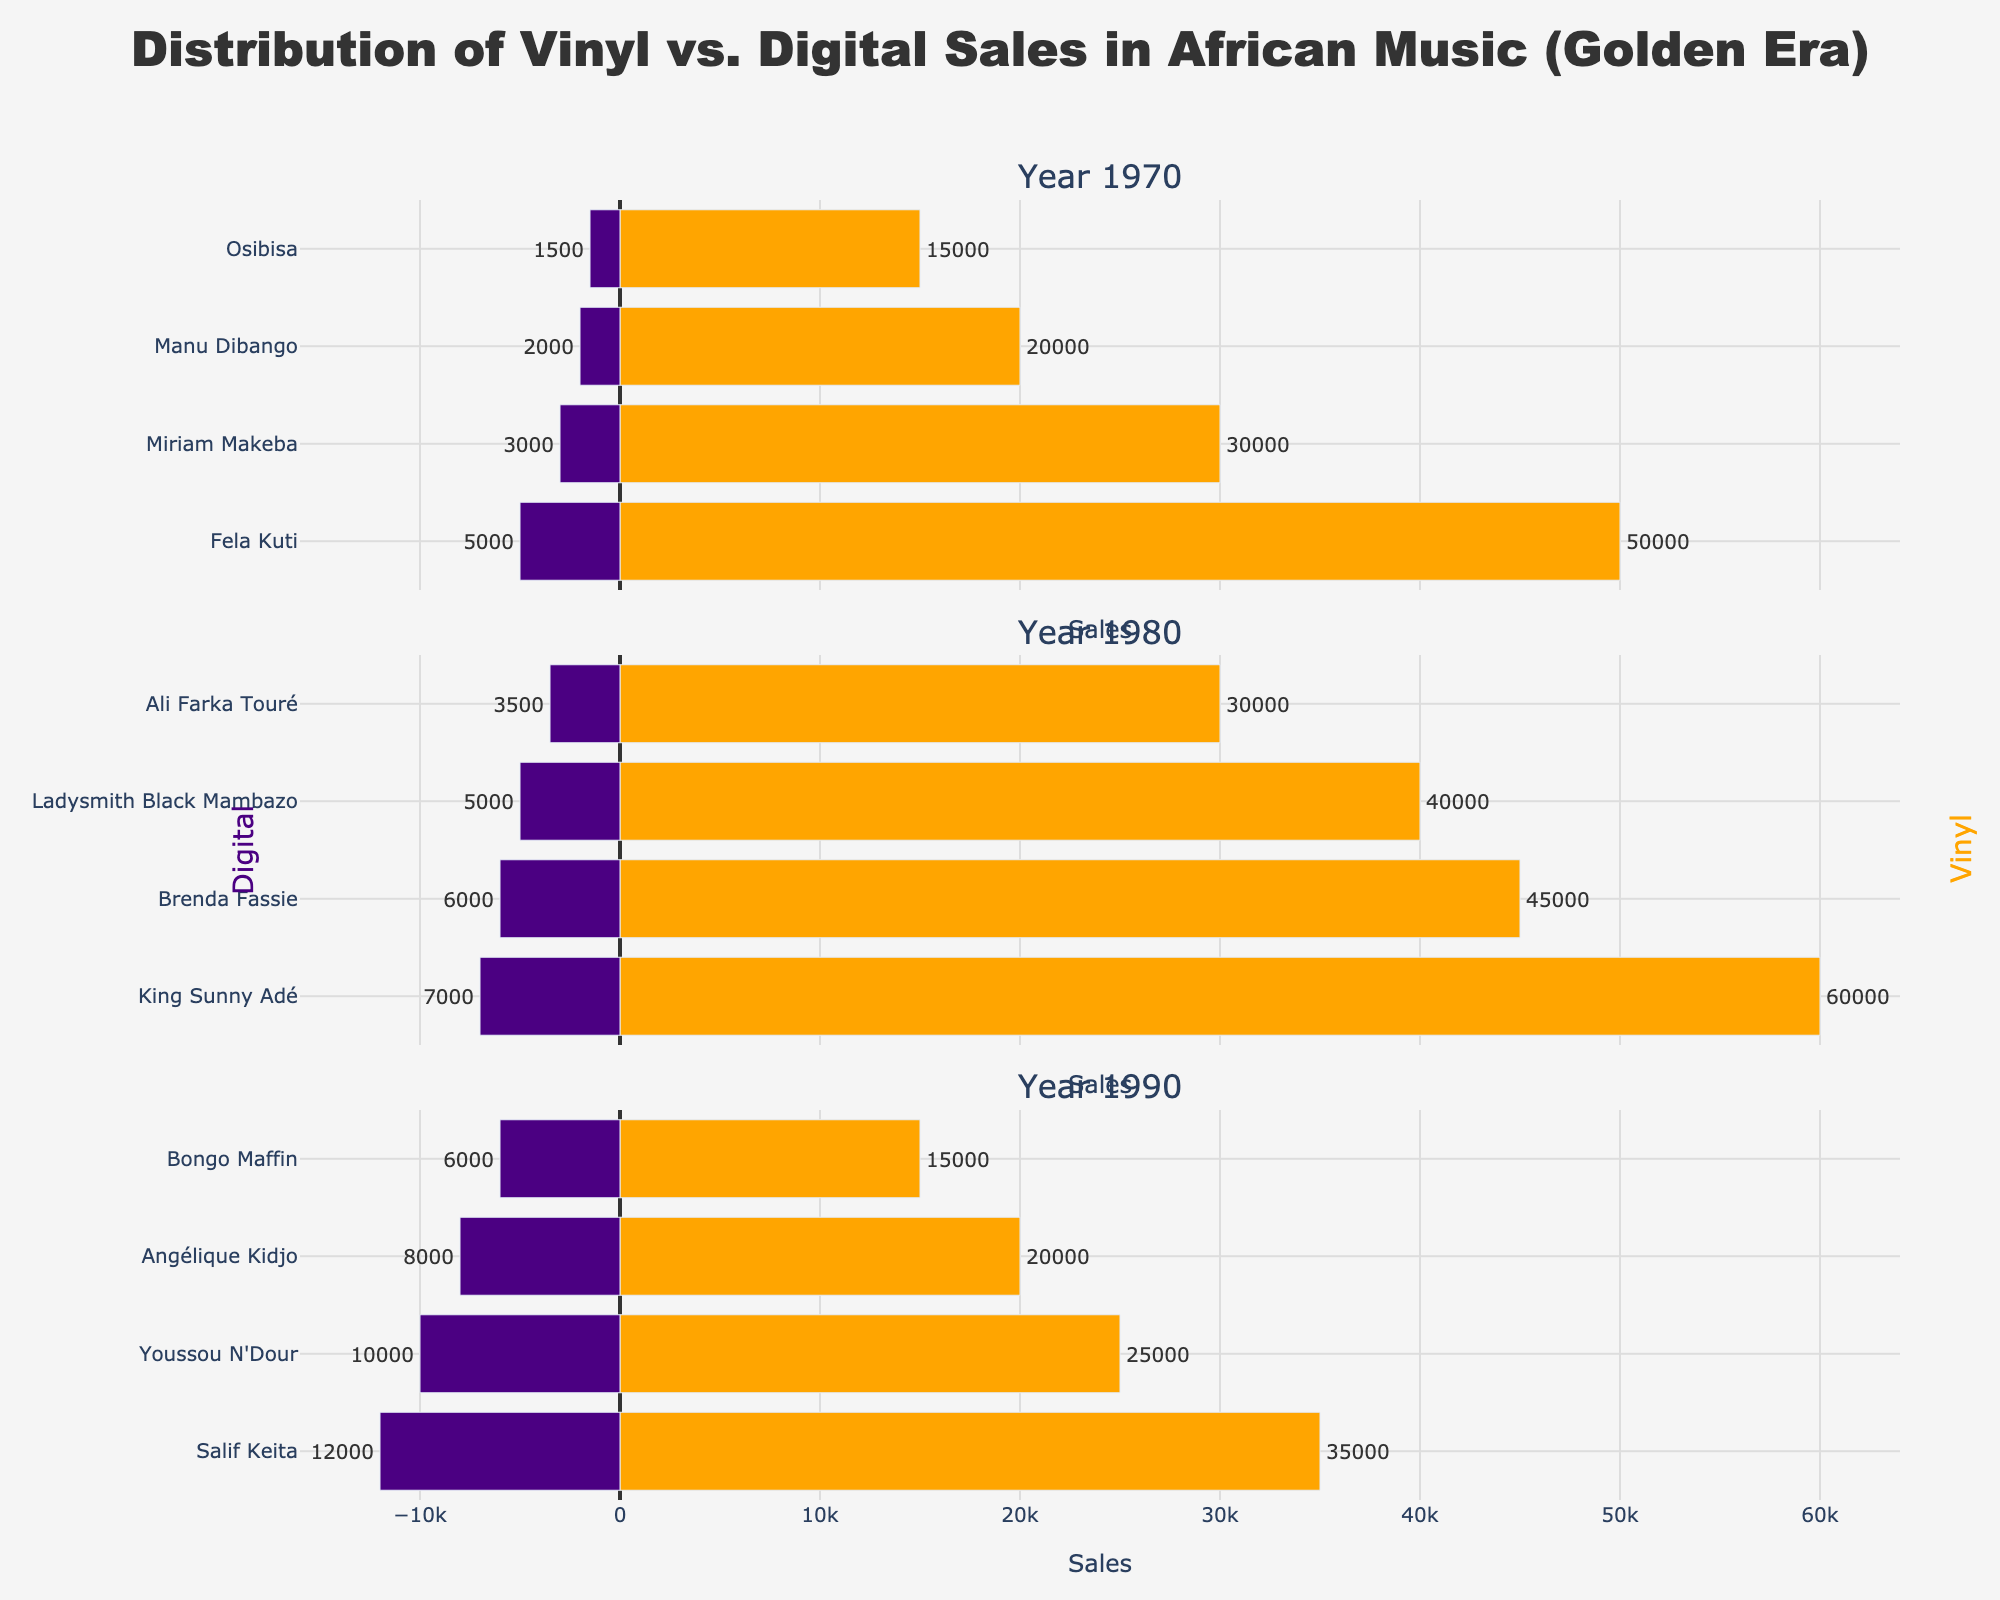Which artist had the highest vinyl sales in 1980? Look at the bars for vinyl sales in 1980 and identify the artist with the longest bar, which is synonymous with the highest sales.
Answer: King Sunny Adé What is the total sales for Fela Kuti in 1970 across both mediums? Find the bars for Fela Kuti in 1970 for both vinyl and digital sales. The vinyl sales are 50,000 and the digital sales are 5,000. Add these together to get the total sales.
Answer: 55,000 Who had higher digital sales in 1990, Salif Keita or Youssou N'Dour? Compare the lengths of the bars representing digital sales for Salif Keita and Youssou N'Dour in 1990. The longer bar indicates higher sales.
Answer: Salif Keita What is the difference in total vinyl sales between the years 1970 and 1980? Sum the vinyl sales for 1970 and 1980 from the respective bars. For 1970, the total is 115,000 (50,000 + 30,000 + 20,000 + 15,000). For 1980, the total is 175,000 (60,000 + 40,000 + 45,000 + 30,000). The difference is 175,000 - 115,000.
Answer: 60,000 Which medium saw greater sales for Miriam Makeba in 1970? Compare the lengths of the bars for Miriam Makeba's vinyl and digital sales in 1970. The longer bar represents the medium with greater sales.
Answer: Vinyl How do the digital sales of Ali Farka Touré in 1980 compare to the digital sales of Angélique Kidjo in 1990? Compare the lengths of the digital sales bars for Ali Farka Touré in 1980 and Angélique Kidjo in 1990. The longer bar indicates higher sales.
Answer: Angélique Kidjo has higher digital sales What is the total combined vinyl sales for King Sunny Adé and Brenda Fassie in 1980? Find the vinyl sales bars for King Sunny Adé and Brenda Fassie in 1980. King Sunny Adé has 60,000 and Brenda Fassie has 45,000. Adding them gives the total sales.
Answer: 105,000 